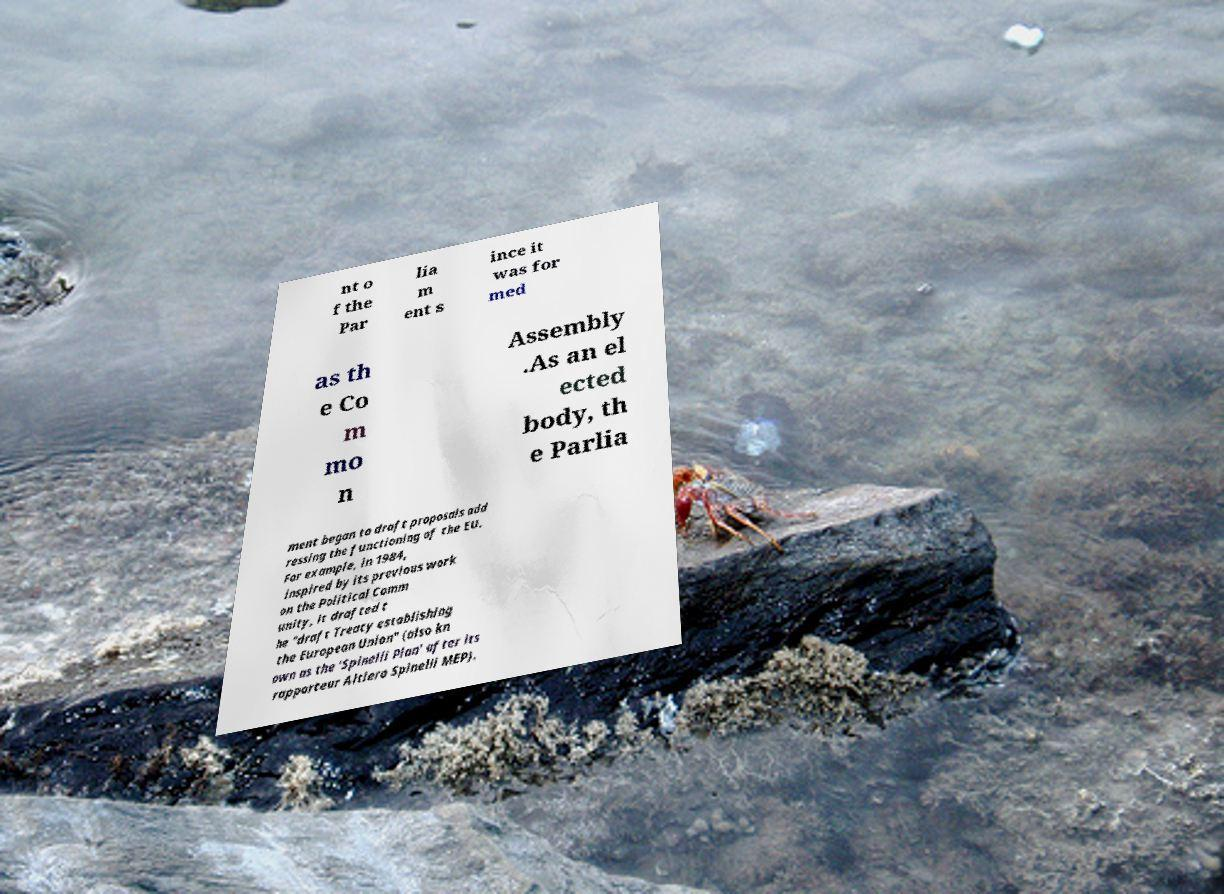What messages or text are displayed in this image? I need them in a readable, typed format. nt o f the Par lia m ent s ince it was for med as th e Co m mo n Assembly .As an el ected body, th e Parlia ment began to draft proposals add ressing the functioning of the EU. For example, in 1984, inspired by its previous work on the Political Comm unity, it drafted t he "draft Treaty establishing the European Union" (also kn own as the 'Spinelli Plan' after its rapporteur Altiero Spinelli MEP). 